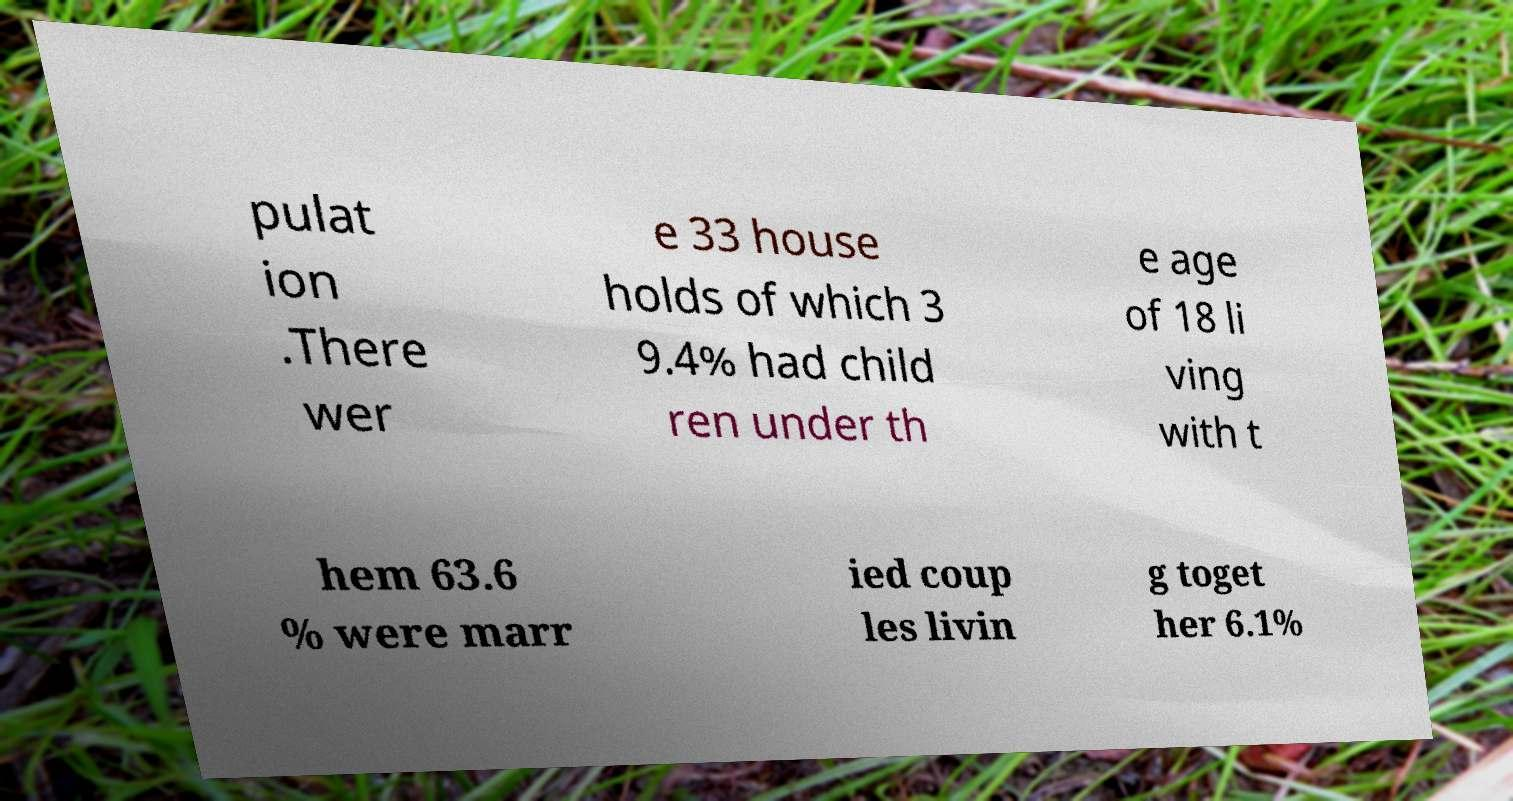Please read and relay the text visible in this image. What does it say? pulat ion .There wer e 33 house holds of which 3 9.4% had child ren under th e age of 18 li ving with t hem 63.6 % were marr ied coup les livin g toget her 6.1% 